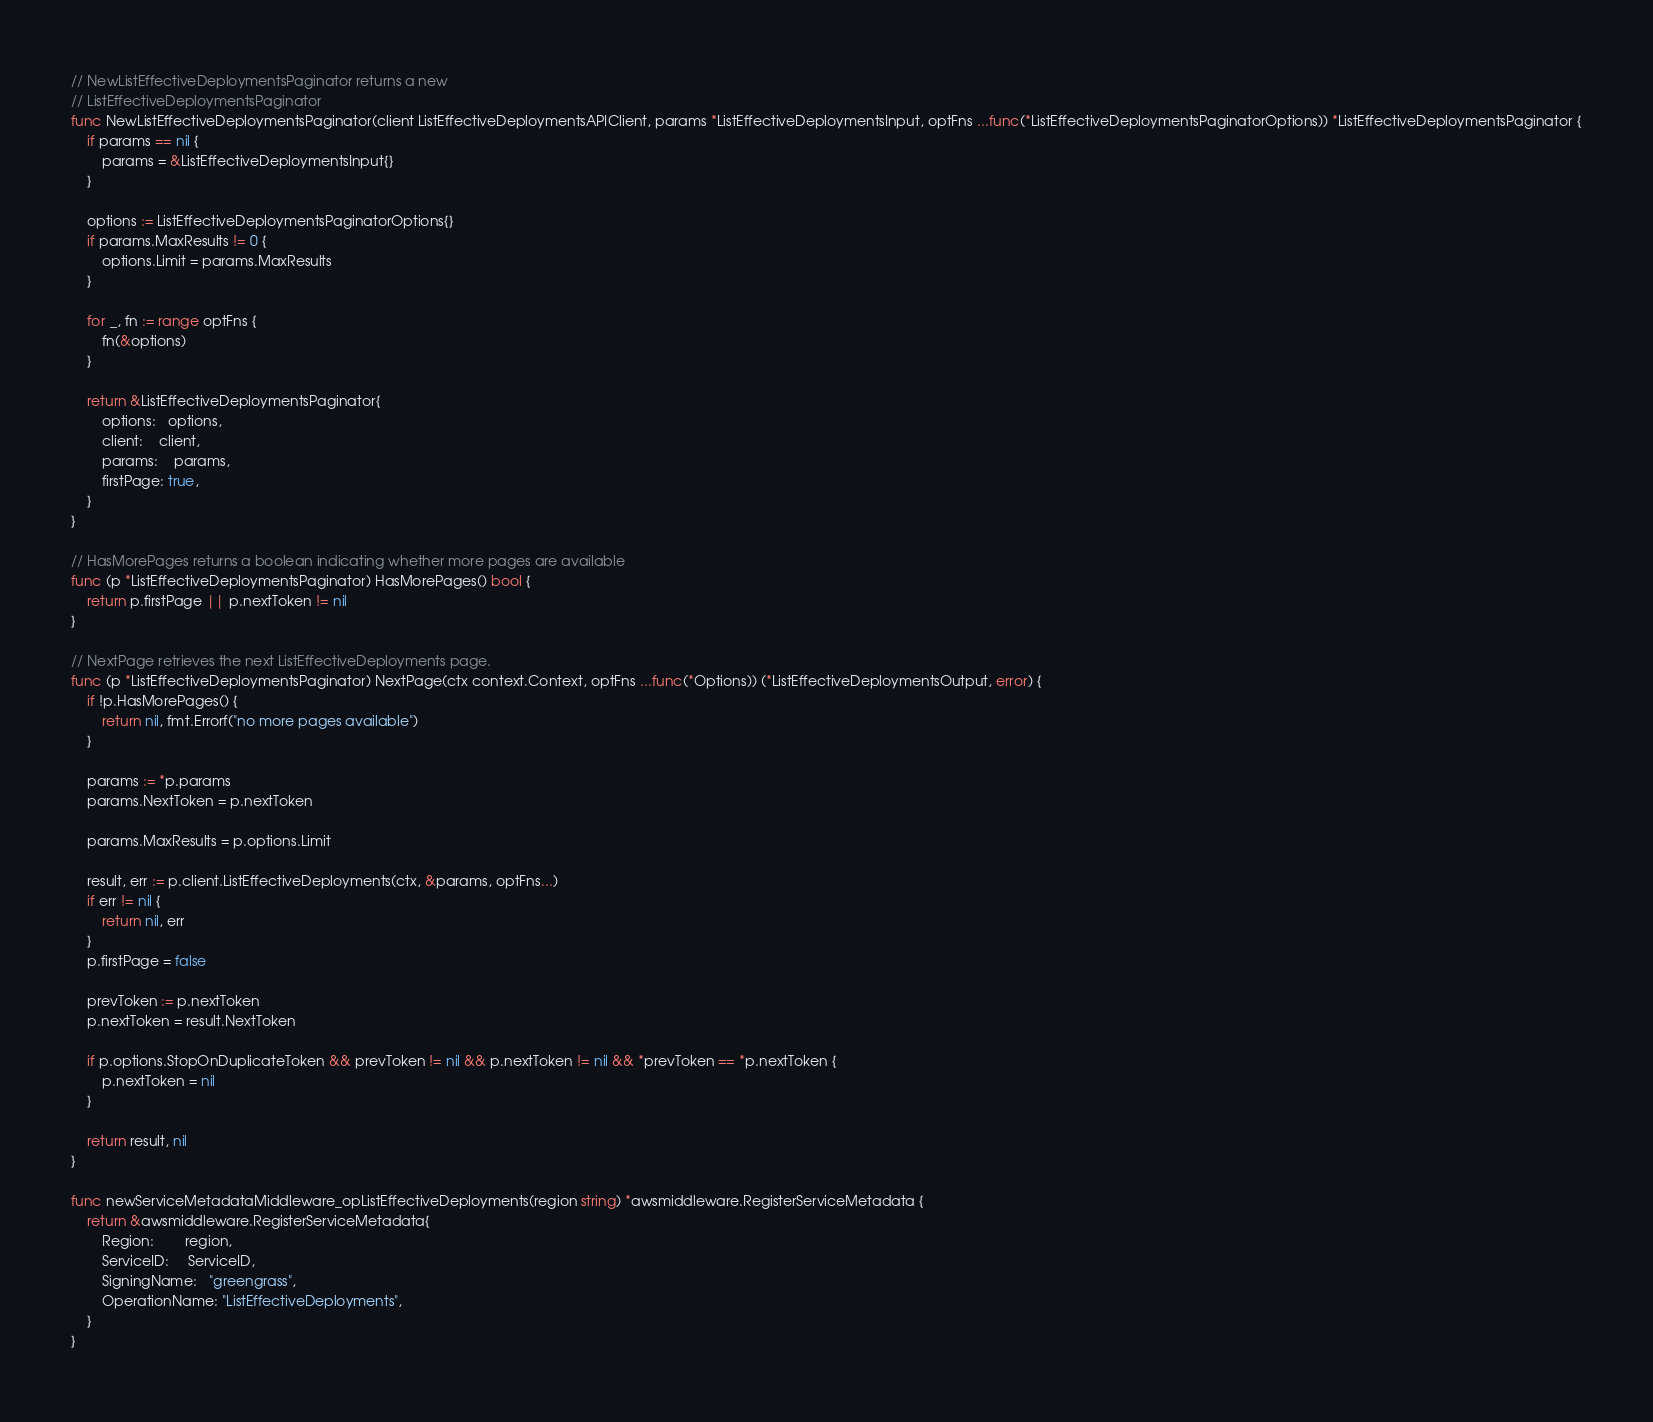<code> <loc_0><loc_0><loc_500><loc_500><_Go_>// NewListEffectiveDeploymentsPaginator returns a new
// ListEffectiveDeploymentsPaginator
func NewListEffectiveDeploymentsPaginator(client ListEffectiveDeploymentsAPIClient, params *ListEffectiveDeploymentsInput, optFns ...func(*ListEffectiveDeploymentsPaginatorOptions)) *ListEffectiveDeploymentsPaginator {
	if params == nil {
		params = &ListEffectiveDeploymentsInput{}
	}

	options := ListEffectiveDeploymentsPaginatorOptions{}
	if params.MaxResults != 0 {
		options.Limit = params.MaxResults
	}

	for _, fn := range optFns {
		fn(&options)
	}

	return &ListEffectiveDeploymentsPaginator{
		options:   options,
		client:    client,
		params:    params,
		firstPage: true,
	}
}

// HasMorePages returns a boolean indicating whether more pages are available
func (p *ListEffectiveDeploymentsPaginator) HasMorePages() bool {
	return p.firstPage || p.nextToken != nil
}

// NextPage retrieves the next ListEffectiveDeployments page.
func (p *ListEffectiveDeploymentsPaginator) NextPage(ctx context.Context, optFns ...func(*Options)) (*ListEffectiveDeploymentsOutput, error) {
	if !p.HasMorePages() {
		return nil, fmt.Errorf("no more pages available")
	}

	params := *p.params
	params.NextToken = p.nextToken

	params.MaxResults = p.options.Limit

	result, err := p.client.ListEffectiveDeployments(ctx, &params, optFns...)
	if err != nil {
		return nil, err
	}
	p.firstPage = false

	prevToken := p.nextToken
	p.nextToken = result.NextToken

	if p.options.StopOnDuplicateToken && prevToken != nil && p.nextToken != nil && *prevToken == *p.nextToken {
		p.nextToken = nil
	}

	return result, nil
}

func newServiceMetadataMiddleware_opListEffectiveDeployments(region string) *awsmiddleware.RegisterServiceMetadata {
	return &awsmiddleware.RegisterServiceMetadata{
		Region:        region,
		ServiceID:     ServiceID,
		SigningName:   "greengrass",
		OperationName: "ListEffectiveDeployments",
	}
}
</code> 